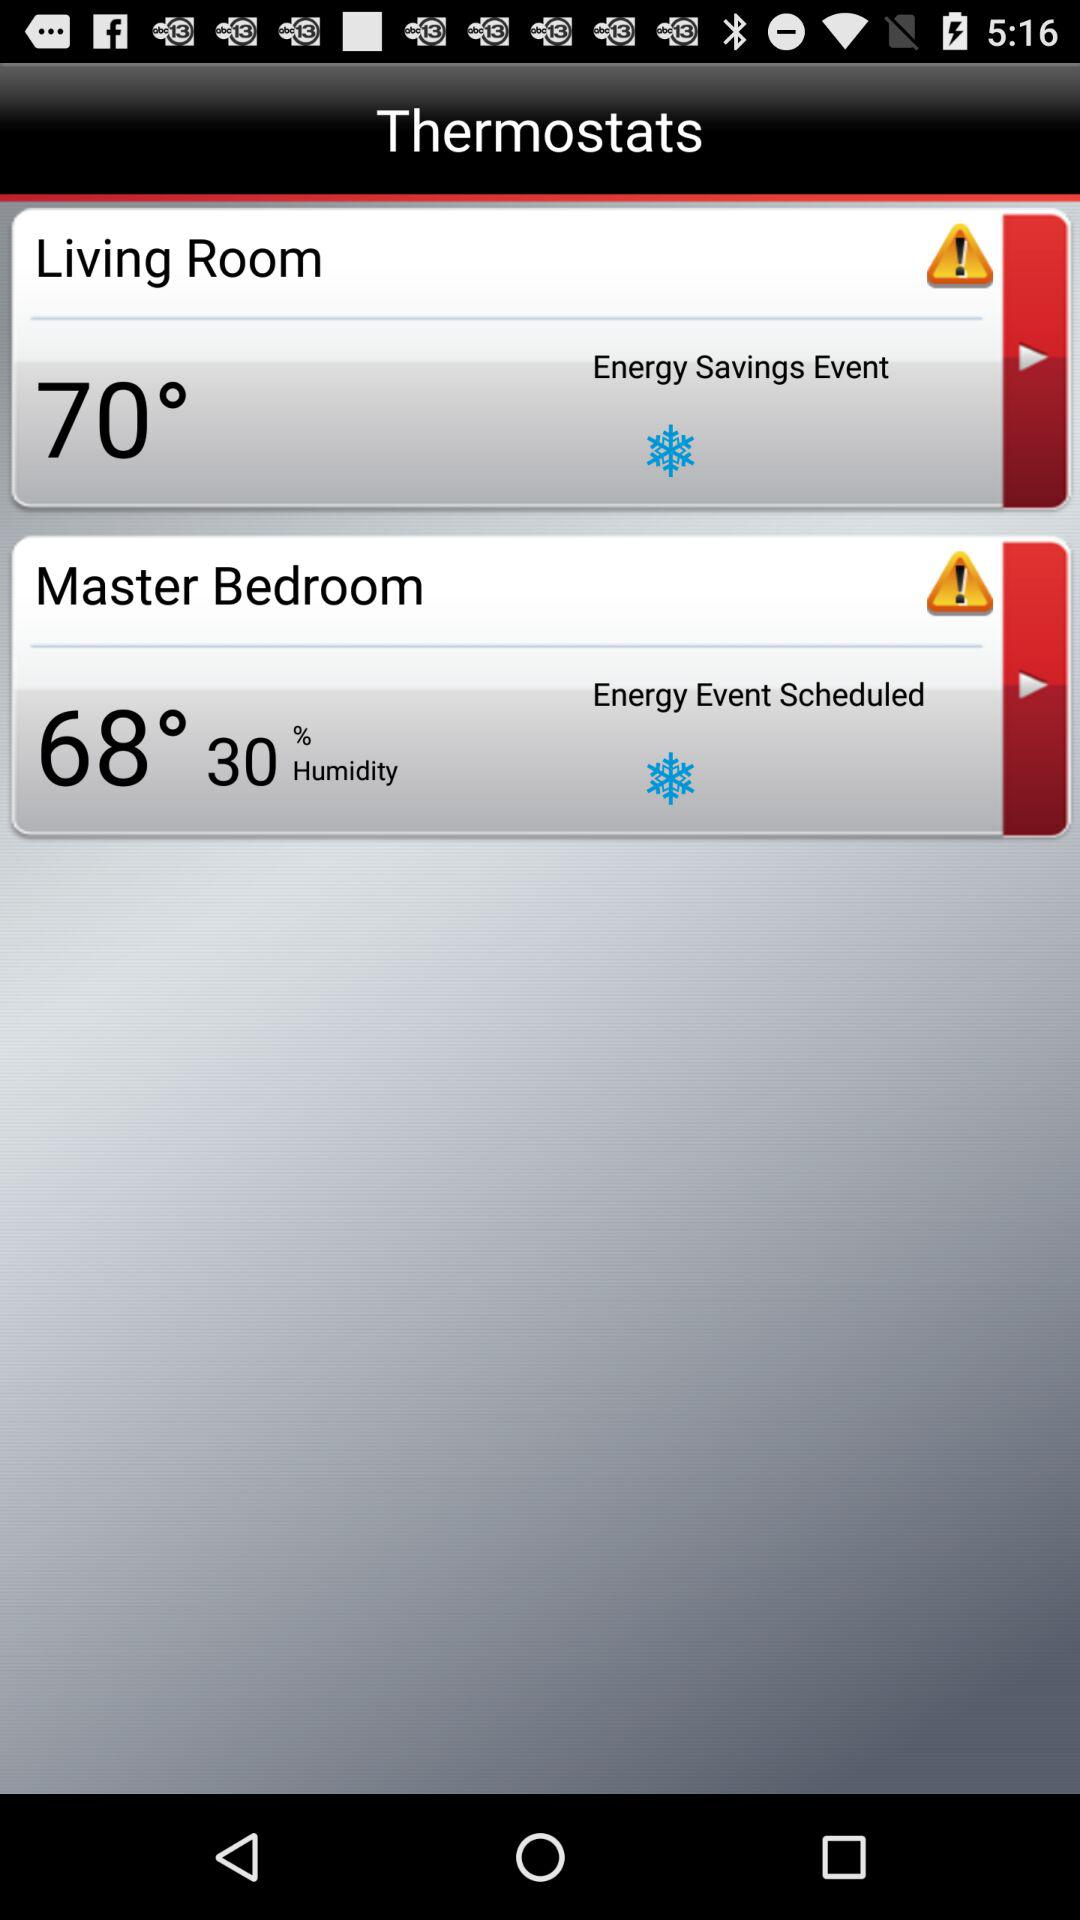What is the temperature of the master bedroom? The temperature of the master bedroom is 68°. 